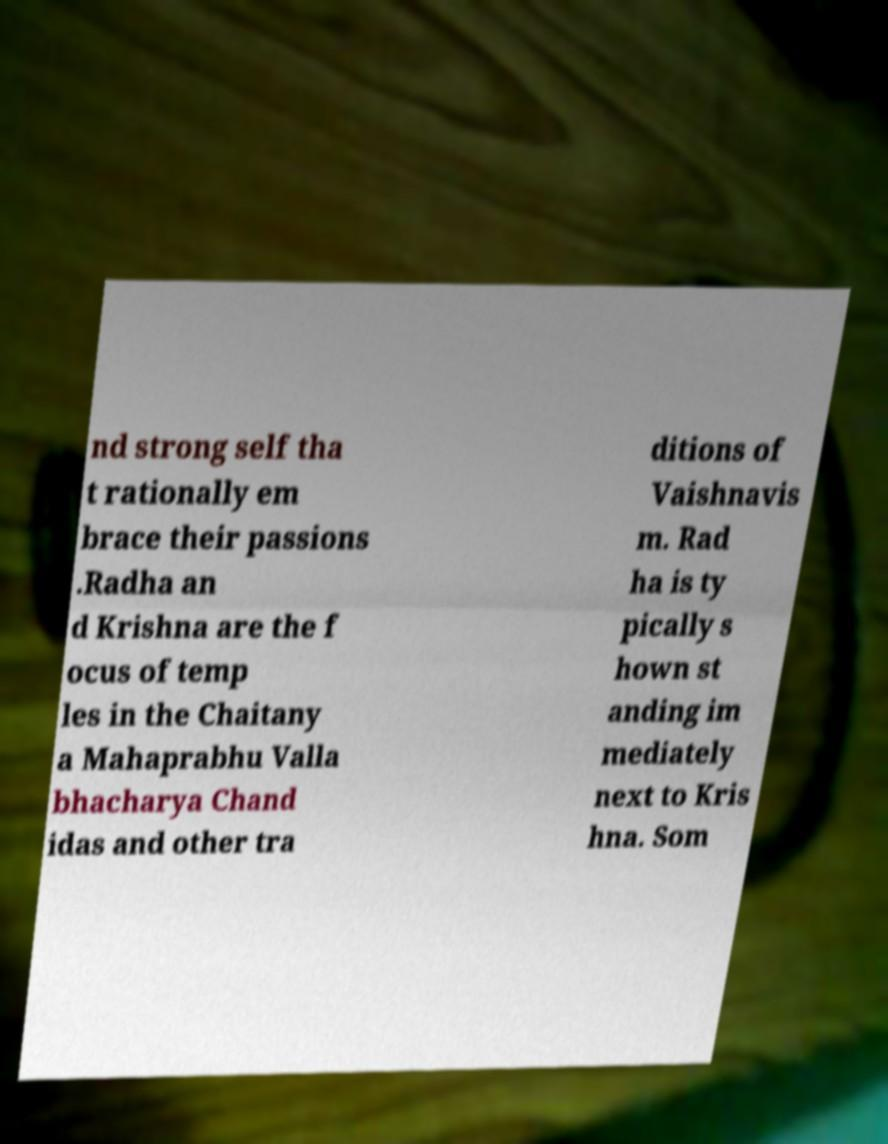For documentation purposes, I need the text within this image transcribed. Could you provide that? nd strong self tha t rationally em brace their passions .Radha an d Krishna are the f ocus of temp les in the Chaitany a Mahaprabhu Valla bhacharya Chand idas and other tra ditions of Vaishnavis m. Rad ha is ty pically s hown st anding im mediately next to Kris hna. Som 